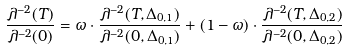Convert formula to latex. <formula><loc_0><loc_0><loc_500><loc_500>\frac { \lambda ^ { - 2 } ( T ) } { \lambda ^ { - 2 } ( 0 ) } = \omega \cdot \frac { \lambda ^ { - 2 } ( T , \Delta _ { 0 , 1 } ) } { \lambda ^ { - 2 } ( 0 , \Delta _ { 0 , 1 } ) } + ( 1 - \omega ) \cdot \frac { \lambda ^ { - 2 } ( T , \Delta _ { 0 , 2 } ) } { \lambda ^ { - 2 } ( 0 , \Delta _ { 0 , 2 } ) }</formula> 